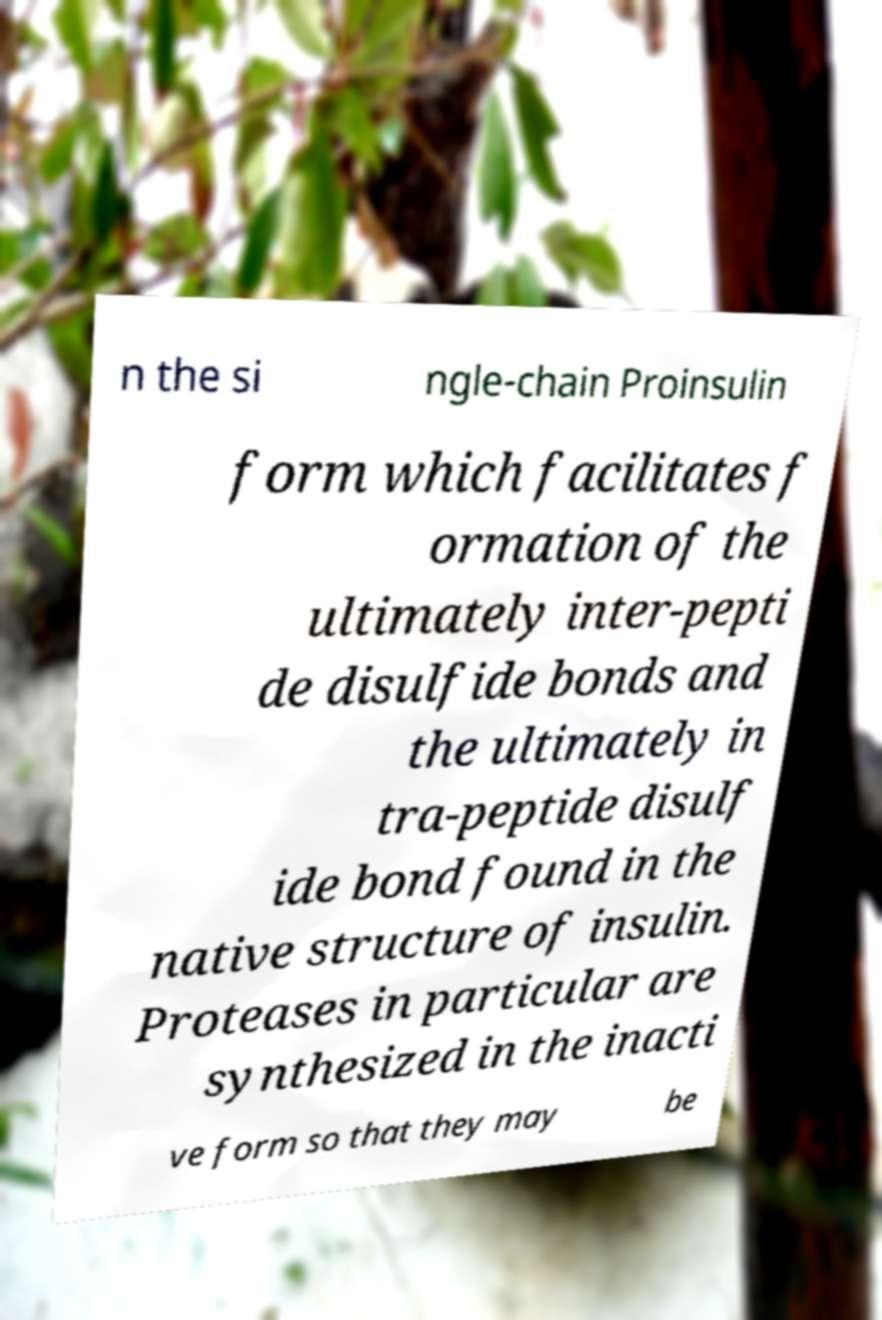What messages or text are displayed in this image? I need them in a readable, typed format. n the si ngle-chain Proinsulin form which facilitates f ormation of the ultimately inter-pepti de disulfide bonds and the ultimately in tra-peptide disulf ide bond found in the native structure of insulin. Proteases in particular are synthesized in the inacti ve form so that they may be 